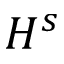Convert formula to latex. <formula><loc_0><loc_0><loc_500><loc_500>H ^ { s }</formula> 